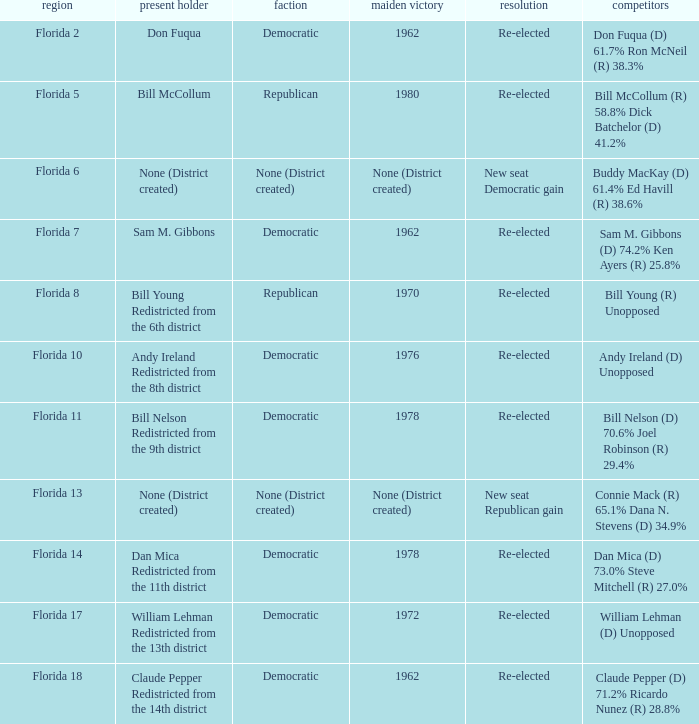 how many result with district being florida 14 1.0. 